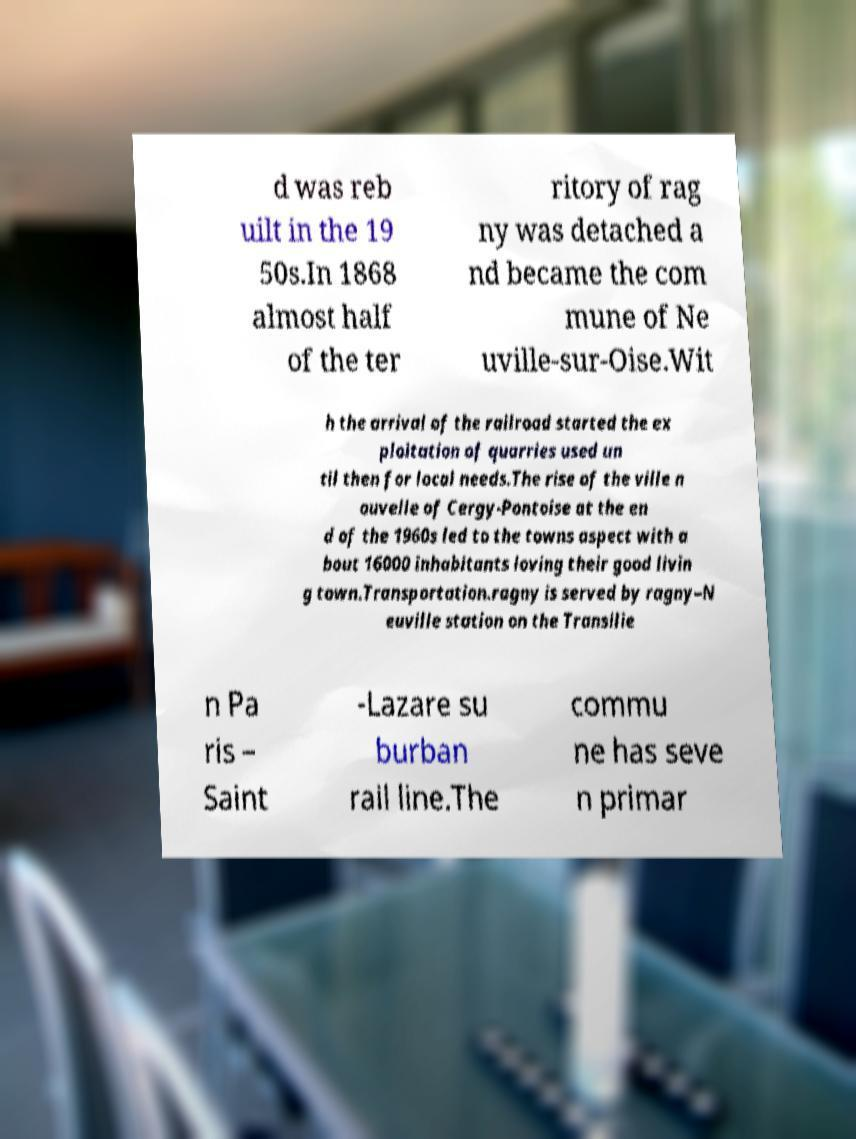Can you accurately transcribe the text from the provided image for me? d was reb uilt in the 19 50s.In 1868 almost half of the ter ritory of rag ny was detached a nd became the com mune of Ne uville-sur-Oise.Wit h the arrival of the railroad started the ex ploitation of quarries used un til then for local needs.The rise of the ville n ouvelle of Cergy-Pontoise at the en d of the 1960s led to the towns aspect with a bout 16000 inhabitants loving their good livin g town.Transportation.ragny is served by ragny–N euville station on the Transilie n Pa ris – Saint -Lazare su burban rail line.The commu ne has seve n primar 